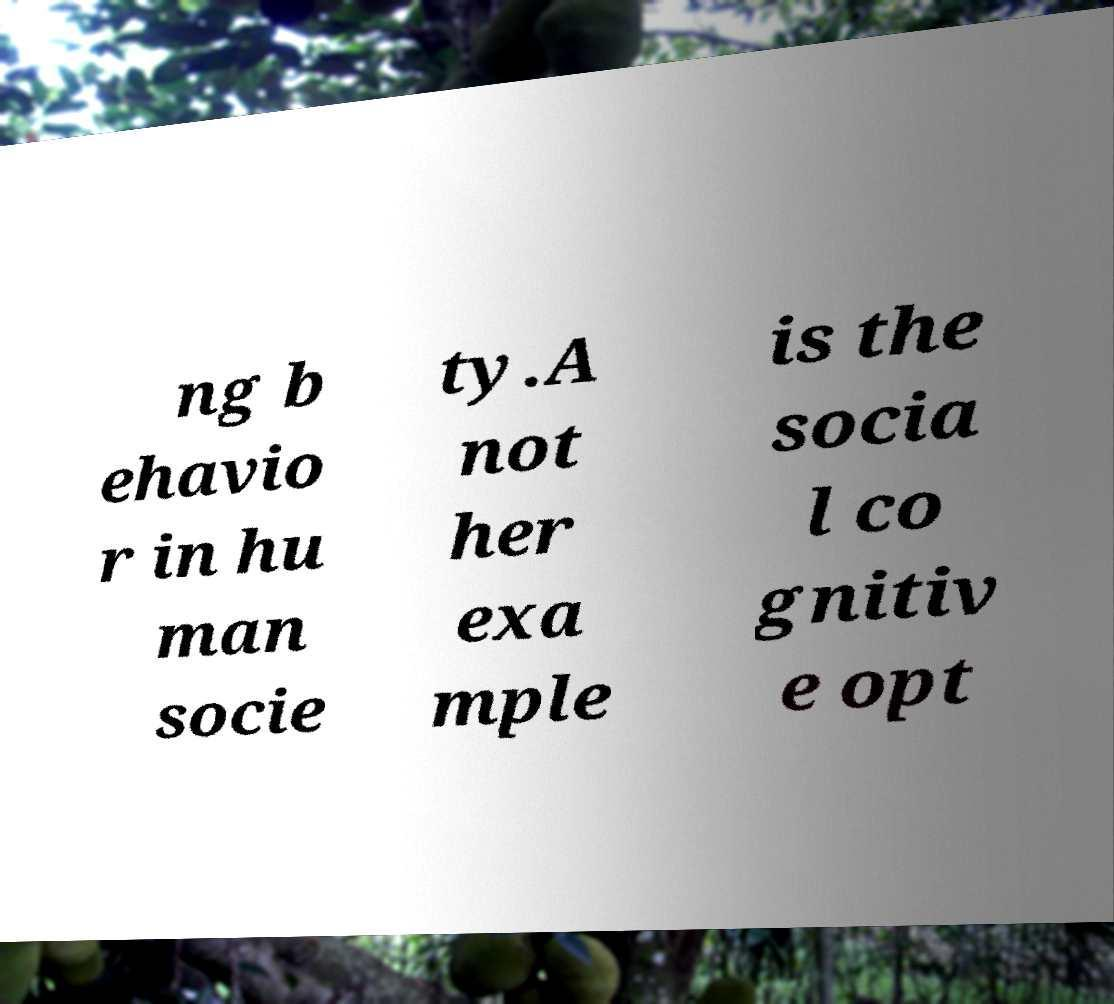Please identify and transcribe the text found in this image. ng b ehavio r in hu man socie ty.A not her exa mple is the socia l co gnitiv e opt 